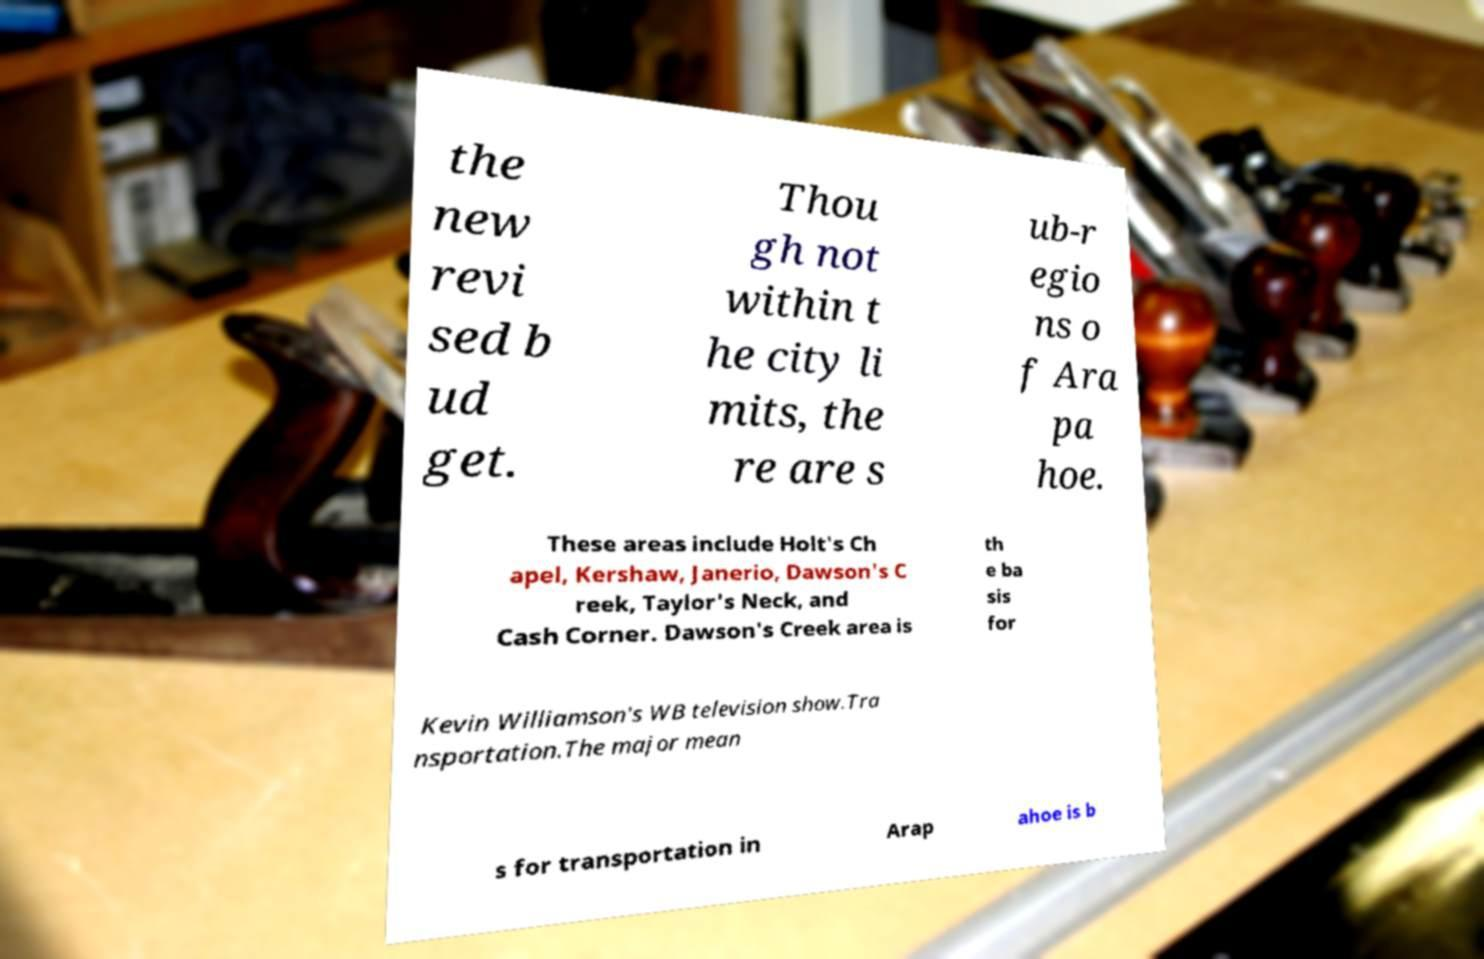Please identify and transcribe the text found in this image. the new revi sed b ud get. Thou gh not within t he city li mits, the re are s ub-r egio ns o f Ara pa hoe. These areas include Holt's Ch apel, Kershaw, Janerio, Dawson's C reek, Taylor's Neck, and Cash Corner. Dawson's Creek area is th e ba sis for Kevin Williamson's WB television show.Tra nsportation.The major mean s for transportation in Arap ahoe is b 